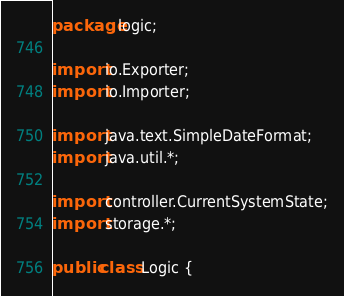<code> <loc_0><loc_0><loc_500><loc_500><_Java_>package logic;

import io.Exporter;
import io.Importer;

import java.text.SimpleDateFormat;
import java.util.*;

import controller.CurrentSystemState;
import storage.*;

public class Logic {
</code> 